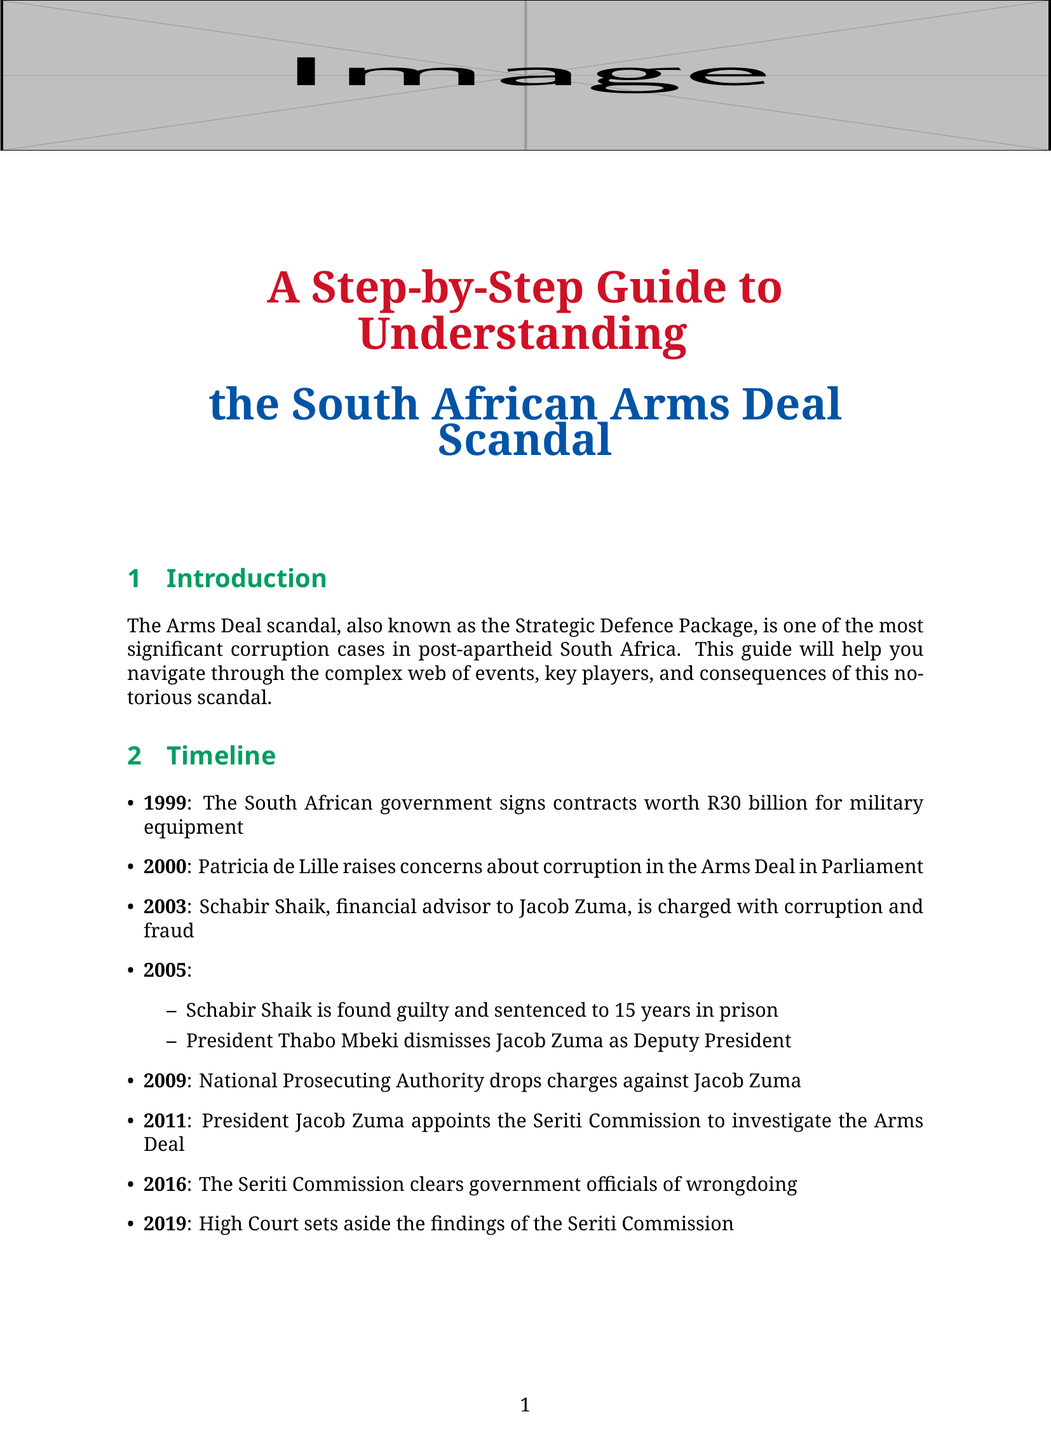What year did the South African government sign contracts for military equipment? The document states that the contracts were signed in 1999.
Answer: 1999 Who raised concerns about corruption in the Arms Deal in Parliament? Patricia de Lille is identified as the whistleblower who raised concerns in Parliament in 2000.
Answer: Patricia de Lille What was the total value of the contracts signed for military equipment? The document mentions that the contracts were worth R30 billion.
Answer: R30 billion What was the outcome for Schabir Shaik in 2005? The document reveals that Schabir Shaik was found guilty and sentenced to prison.
Answer: Sentenced to 15 years in prison Which commission did President Jacob Zuma appoint to investigate the Arms Deal? The guide states that the Seriti Commission was appointed to investigate the Arms Deal in 2011.
Answer: Seriti Commission What were the allegations of corruption related to the Arms Deal? The document lists several allegations, including inflated prices and unnecessary purchases.
Answer: Inflated prices and unnecessary purchases Who was the head of the Commission of Inquiry into the Arms Deal? The document identifies Judge Willie Seriti as the head of the inquiry.
Answer: Judge Willie Seriti Which company supplied the Hawk and Gripen fighter jets? BAE Systems is noted as the supplier of the fighter jets in the document.
Answer: BAE Systems What is one lesson learned from the Arms Deal scandal? The document emphasizes the importance of transparency in government procurement as a lesson learned.
Answer: Transparency in government procurement 